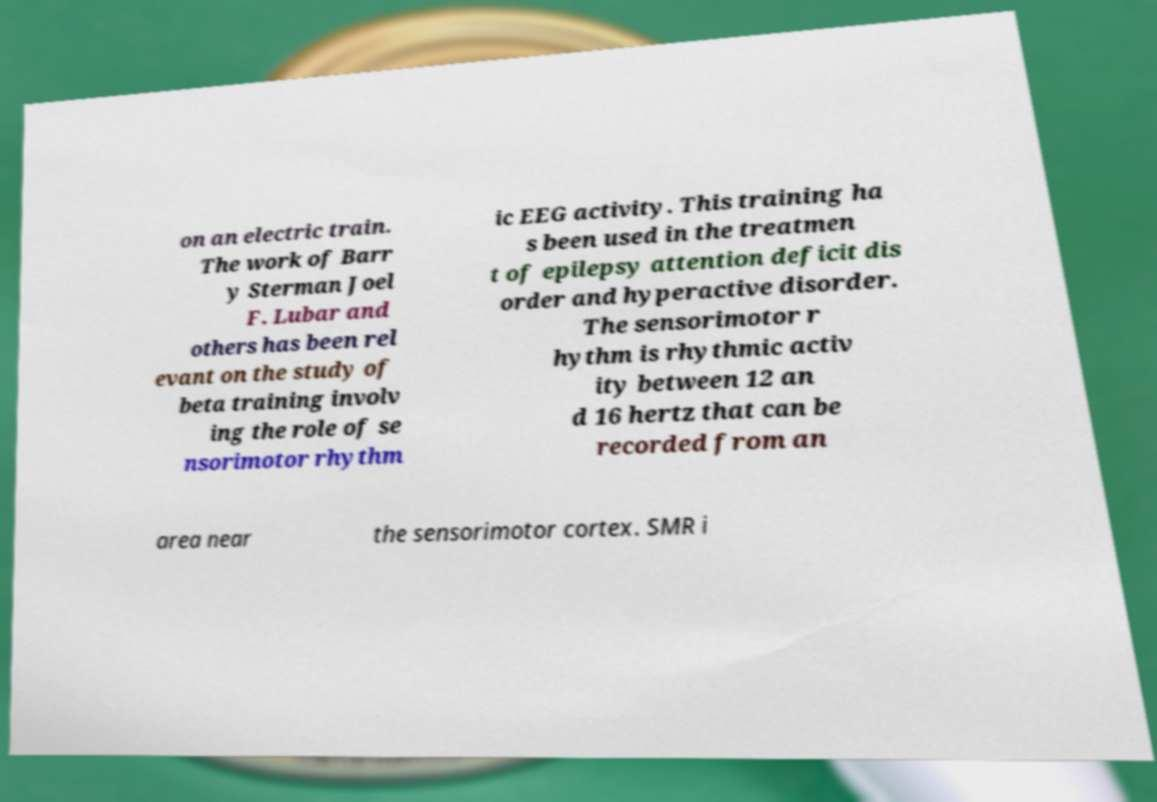Please read and relay the text visible in this image. What does it say? on an electric train. The work of Barr y Sterman Joel F. Lubar and others has been rel evant on the study of beta training involv ing the role of se nsorimotor rhythm ic EEG activity. This training ha s been used in the treatmen t of epilepsy attention deficit dis order and hyperactive disorder. The sensorimotor r hythm is rhythmic activ ity between 12 an d 16 hertz that can be recorded from an area near the sensorimotor cortex. SMR i 